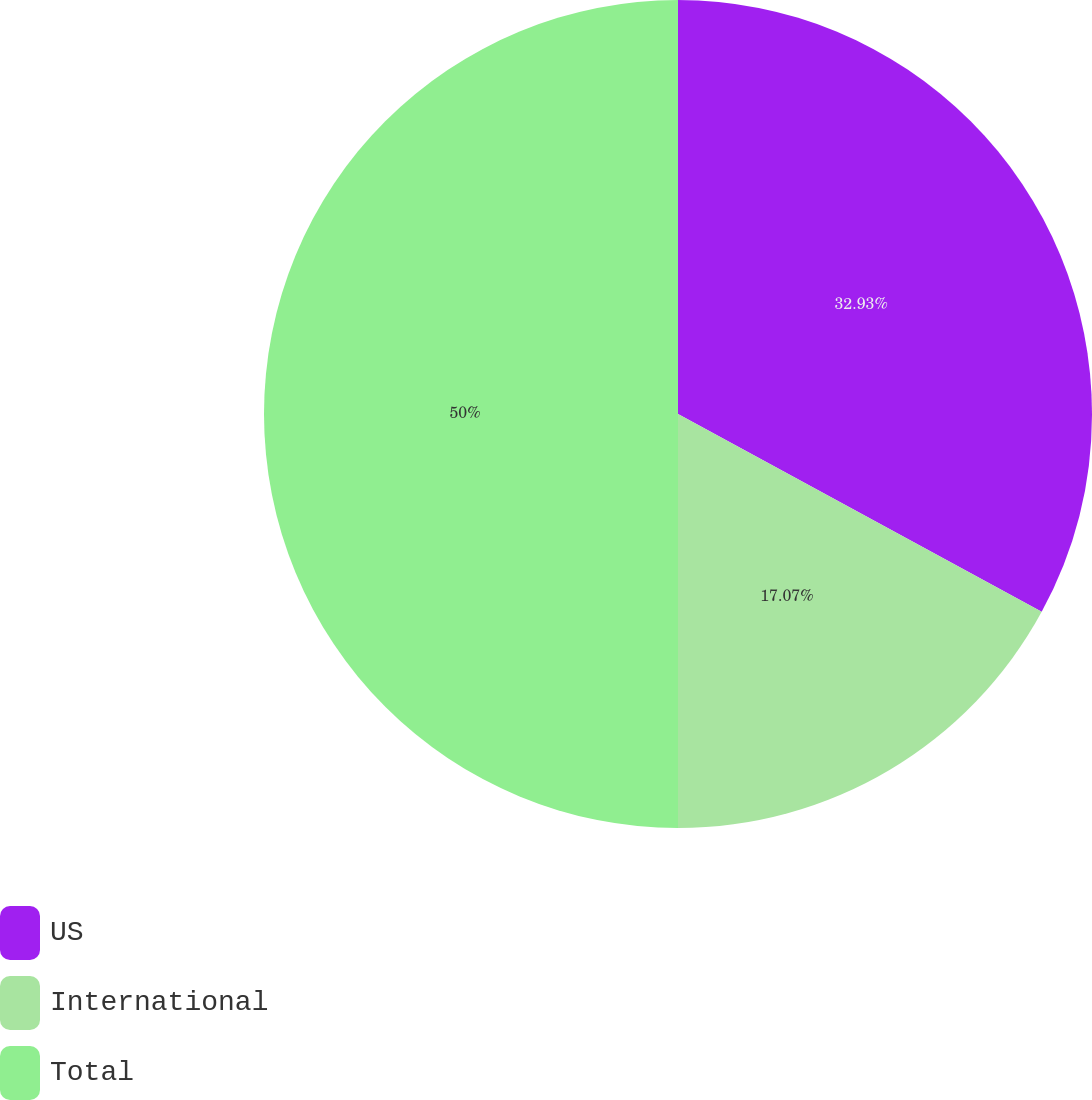Convert chart to OTSL. <chart><loc_0><loc_0><loc_500><loc_500><pie_chart><fcel>US<fcel>International<fcel>Total<nl><fcel>32.93%<fcel>17.07%<fcel>50.0%<nl></chart> 